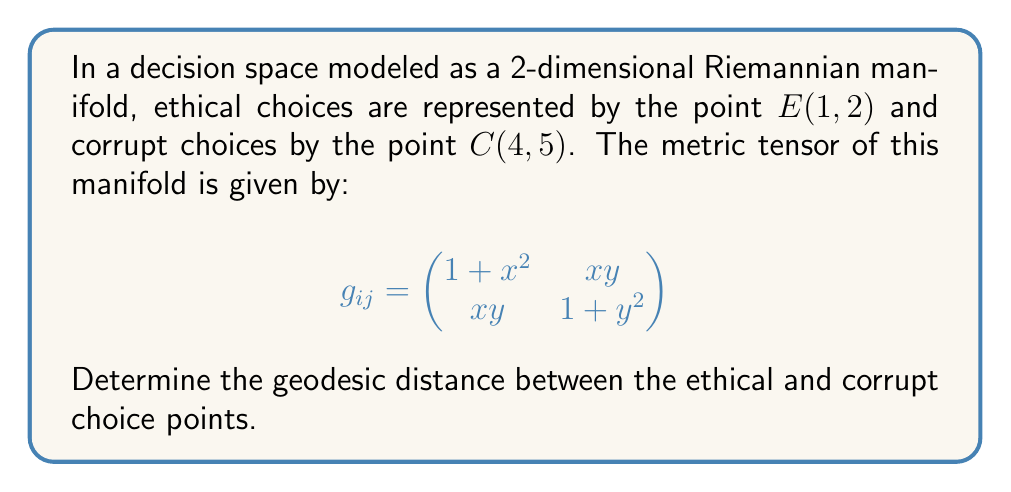Help me with this question. To find the geodesic distance between two points on a Riemannian manifold, we need to solve the geodesic equation and minimize the path length. However, for a general metric tensor, this can be a complex process. Instead, we can use an approximation method.

1) First, we'll calculate the straight-line distance between E and C:
   $\Delta x = 4 - 1 = 3$, $\Delta y = 5 - 2 = 3$

2) The midpoint of the path is:
   $M = (\frac{1+4}{2}, \frac{2+5}{2}) = (2.5, 3.5)$

3) We'll evaluate the metric tensor at this midpoint:

   $$g_{ij}(2.5, 3.5) = \begin{pmatrix}
   1 + (2.5)^2 & (2.5)(3.5) \\
   (2.5)(3.5) & 1 + (3.5)^2
   \end{pmatrix} = \begin{pmatrix}
   7.25 & 8.75 \\
   8.75 & 13.25
   \end{pmatrix}$$

4) Now, we can approximate the geodesic distance using:

   $$d \approx \sqrt{(\Delta x, \Delta y) \cdot g_{ij}(M) \cdot (\Delta x, \Delta y)^T}$$

5) Calculating:
   $$\begin{aligned}
   d &\approx \sqrt{(3, 3) \cdot \begin{pmatrix}
   7.25 & 8.75 \\
   8.75 & 13.25
   \end{pmatrix} \cdot \begin{pmatrix}
   3 \\
   3
   \end{pmatrix}} \\
   &= \sqrt{(3, 3) \cdot \begin{pmatrix}
   48 \\
   66
   \end{pmatrix}} \\
   &= \sqrt{3(48) + 3(66)} \\
   &= \sqrt{342} \\
   &\approx 18.49
   \end{aligned}$$

This approximation gives us the geodesic distance between the ethical and corrupt choice points in the decision space.
Answer: The approximate geodesic distance between the ethical choice point $E(1, 2)$ and the corrupt choice point $C(4, 5)$ in the given decision space is $\sqrt{342} \approx 18.49$ units. 